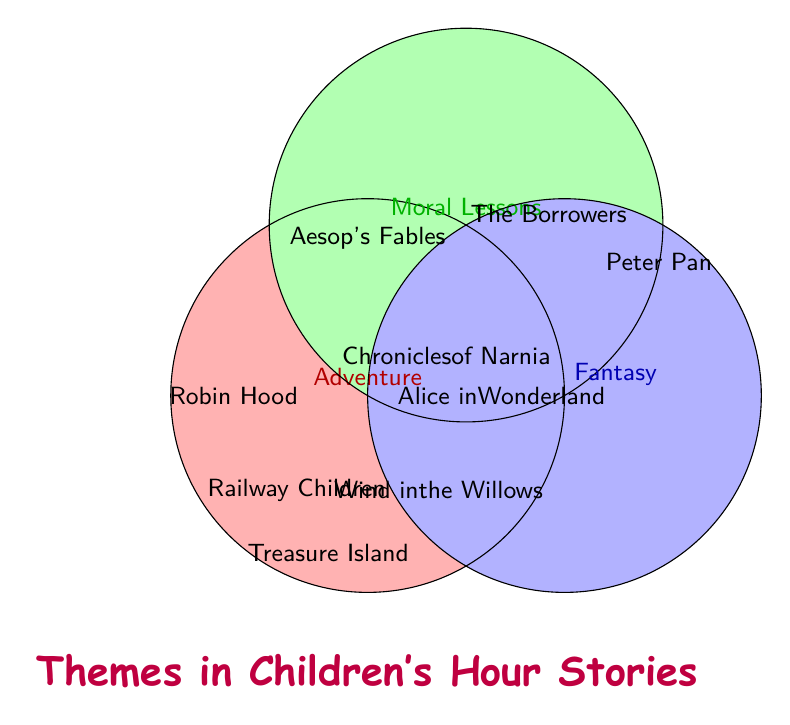Which theme is associated with 'Peter Pan'? 'Peter Pan' is located within the 'Fantasy' circle, and the 'Adventure' circle as it appears in the blue and red overlapping section.
Answer: Fantasy and Adventure How many stories include moral lessons? Count the number of stories listed in the green circle and its overlapping sections. These include 'Robin Hood', 'The Railway Children', 'Aesop's Fables', 'The Borrowers', 'Treasure Island', and 'The Chronicles of Narnia'.
Answer: 6 Which story includes all three themes? Identify the story found in the overlapping section of all three circles: red (Adventure), green (Moral Lessons), and blue (Fantasy). 'The Chronicles of Narnia' fits this criterion.
Answer: The Chronicles of Narnia Which story is only associated with moral lessons? Look in the green circle where there is no overlap with the red or blue circles. 'Aesop's Fables' is the story that fits this description.
Answer: Aesop's Fables How many stories are associated with both adventure and moral lessons but not fantasy? Identify stories in the overlapping section of red (Adventure) and green (Moral Lessons), excluding the area overlapping with blue (Fantasy). These are 'Robin Hood', 'The Railway Children', and 'Treasure Island'.
Answer: 3 Which stories share the Adventure and Fantasy themes but not Moral Lessons? Check the overlapping section of red (Adventure) and blue (Fantasy), excluding the green (Moral Lessons) section. 'Wind in the Willows' and 'Peter Pan' are found there.
Answer: Wind in the Willows and Peter Pan Which story is only associated with fantasy? Find the story in the blue circle that does not overlap with the red or green circles. 'Alice in Wonderland' is the story that fits this description.
Answer: Alice in Wonderland Are there any stories associated with both moral lessons and fantasy but not adventure? Examine the overlapping section of green (Moral Lessons) and blue (Fantasy) circles, excluding the red (Adventure) circle. 'The Borrowers' fits this description.
Answer: The Borrowers Which story is only associated with adventure? Seek the story in the red circle without any overlap with the green or blue circles. No such story exists in the provided figure.
Answer: None 